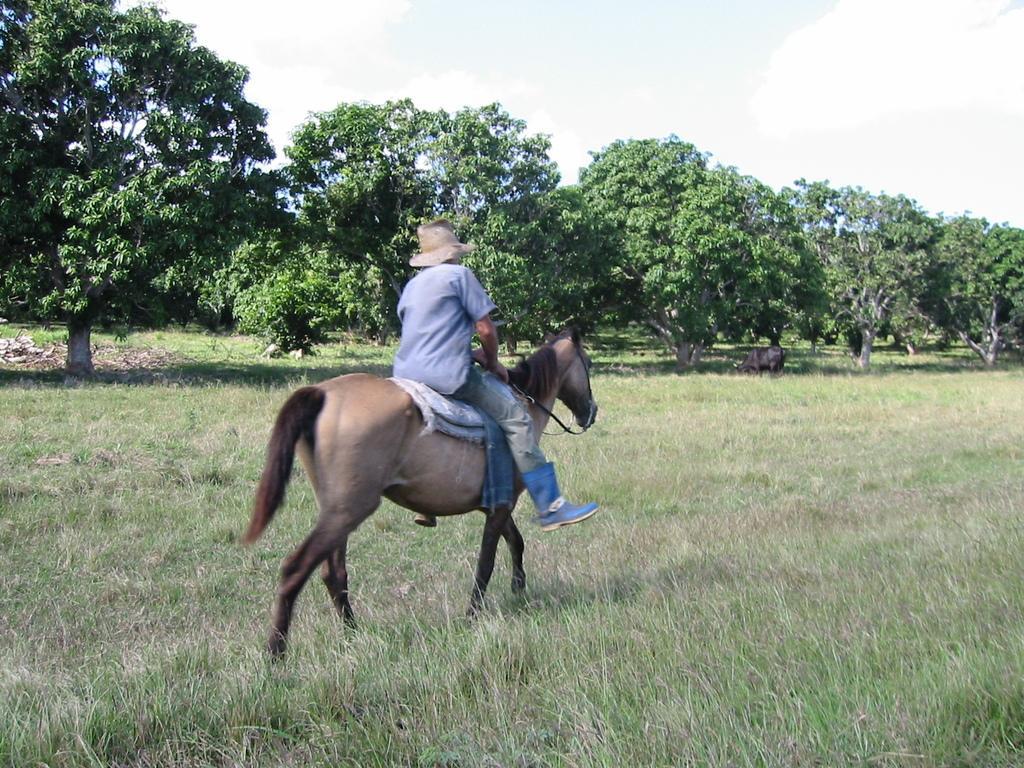Describe this image in one or two sentences. A person is riding a horse wearing a hat, blue shirt, pant and blue boots. There are trees at the back. 